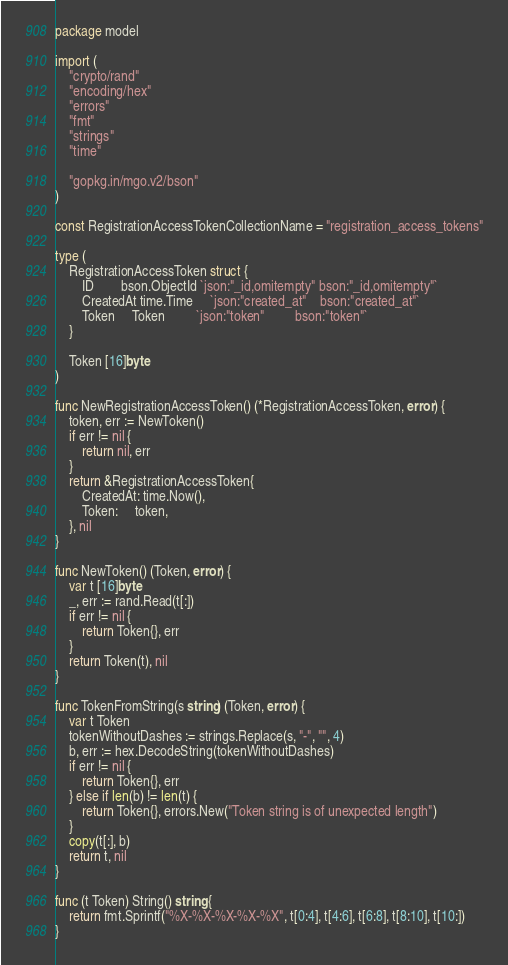<code> <loc_0><loc_0><loc_500><loc_500><_Go_>package model

import (
	"crypto/rand"
	"encoding/hex"
	"errors"
	"fmt"
	"strings"
	"time"

	"gopkg.in/mgo.v2/bson"
)

const RegistrationAccessTokenCollectionName = "registration_access_tokens"

type (
	RegistrationAccessToken struct {
		ID        bson.ObjectId `json:"_id,omitempty" bson:"_id,omitempty"`
		CreatedAt time.Time     `json:"created_at"    bson:"created_at"`
		Token     Token         `json:"token"         bson:"token"`
	}

	Token [16]byte
)

func NewRegistrationAccessToken() (*RegistrationAccessToken, error) {
	token, err := NewToken()
	if err != nil {
		return nil, err
	}
	return &RegistrationAccessToken{
		CreatedAt: time.Now(),
		Token:     token,
	}, nil
}

func NewToken() (Token, error) {
	var t [16]byte
	_, err := rand.Read(t[:])
	if err != nil {
		return Token{}, err
	}
	return Token(t), nil
}

func TokenFromString(s string) (Token, error) {
	var t Token
	tokenWithoutDashes := strings.Replace(s, "-", "", 4)
	b, err := hex.DecodeString(tokenWithoutDashes)
	if err != nil {
		return Token{}, err
	} else if len(b) != len(t) {
		return Token{}, errors.New("Token string is of unexpected length")
	}
	copy(t[:], b)
	return t, nil
}

func (t Token) String() string {
	return fmt.Sprintf("%X-%X-%X-%X-%X", t[0:4], t[4:6], t[6:8], t[8:10], t[10:])
}
</code> 